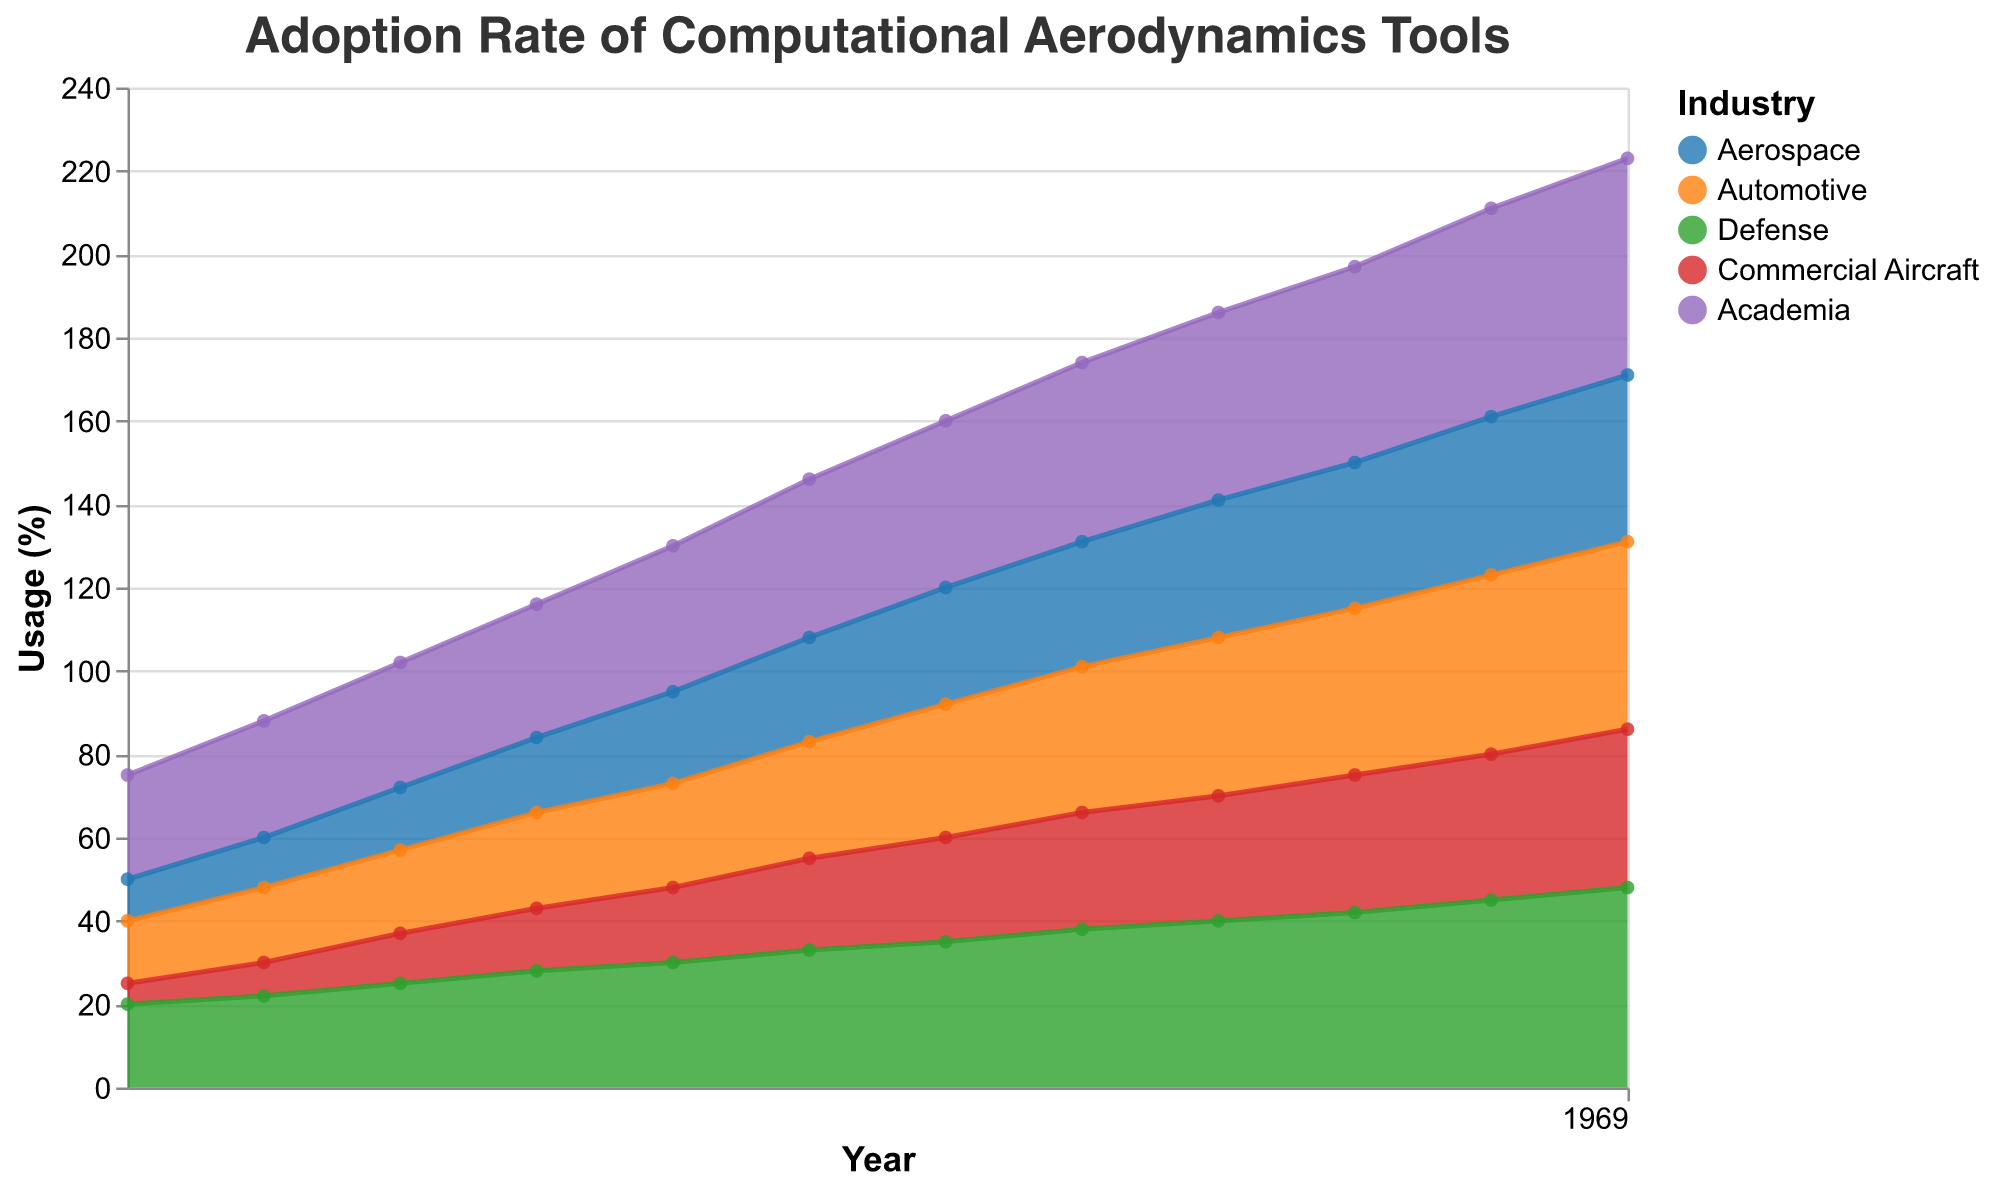How does the adoption rate of computational aerodynamics tools compare between the Commercial Aircraft and Automotive industries in 2010? First, locate the year 2010 on the x-axis. The Commercial Aircraft adoption rate is 22%, and the Automotive adoption rate is 28%. Comparing these values, the Automotive industry has a higher adoption rate.
Answer: Automotive has a higher rate Which industry had the highest adoption rate in 2002? Locate the year 2002 on the x-axis and compare the values for each industry. Aerospace is 12%, Automotive is 18%, Defense is 22%, Commercial Aircraft is 8%, and Academia is 28%. The highest adoption rate is in Academia.
Answer: Academia By how much did the adoption rate increase for the Aerospace industry from 2000 to 2022? Locate the Aerospace adoption rates for the years 2000 (10%) and 2022 (40%). Subtract the 2000 value from the 2022 value: 40% - 10% = 30%.
Answer: 30% Which industry showed the smallest increase in the adoption rate of computational aerodynamics tools between 2000 and 2022? Compare the increase in adoption rates for each industry from 2000 to 2022: Aerospace (40%-10%=30%), Automotive (45%-15%=30%), Defense (48%-20%=28%), Commercial Aircraft (38%-5%=33%), Academia (52%-25%=27%). The smallest increase is in Defense.
Answer: Defense By what percentage did the adoption rate for Academia increase from 2008 to 2022? Locate the Academia adoption rates for the years 2008 (35%) and 2022 (52%). Calculate the increase: 52% - 35% = 17%.
Answer: 17% What is the general trend of the adoption rates for all industries over the years? Review the plot and note that adoption rates for all industries show an upward, increasing trend over time.
Answer: Increasing trend In which year did the Defense industry first reach a 30% adoption rate in computational aerodynamics tools? Locate the point where the Defense industry first reaches or exceeds 30%. This occurs in the year 2008.
Answer: 2008 Which two industries had the closest adoption rates in 2016? Locate the year 2016 and compare the values: Aerospace (33%), Automotive (38%), Defense (40%), Commercial Aircraft (30%), Academia (45%). The closest values are for Commercial Aircraft (30%) and Aerospace (33%), with a difference of 3%.
Answer: Commercial Aircraft and Aerospace Calculate the average adoption rate for Academia between the years 2000 and 2022. Sum the Academia values from each year (25 + 28 + 30 + 32 + 35 + 38 + 40 + 43 + 45 + 47 + 50 + 52 = 465) and divide by the number of data points (12). The average is 465/12 ≈ 38.75%.
Answer: 38.75% Which industry had the largest change in adoption rate between 2014 and 2016? Compare the adoption rates for each industry between 2014 and 2016: Aerospace (30% to 33% = 3%), Automotive (35% to 38% = 3%), Defense (38% to 40% = 2%), Commercial Aircraft (28% to 30% = 2%), Academia (43% to 45% = 2%). Aerospace and Automotive both have the largest change of 3%.
Answer: Aerospace and Automotive 